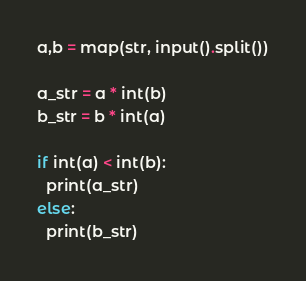<code> <loc_0><loc_0><loc_500><loc_500><_Python_>a,b = map(str, input().split())

a_str = a * int(b)
b_str = b * int(a)

if int(a) < int(b):
  print(a_str)
else:
  print(b_str)</code> 